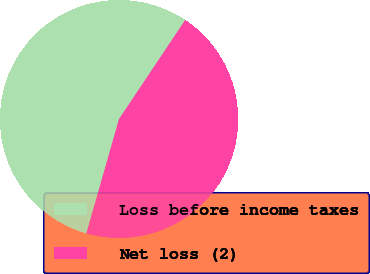<chart> <loc_0><loc_0><loc_500><loc_500><pie_chart><fcel>Loss before income taxes<fcel>Net loss (2)<nl><fcel>54.94%<fcel>45.06%<nl></chart> 